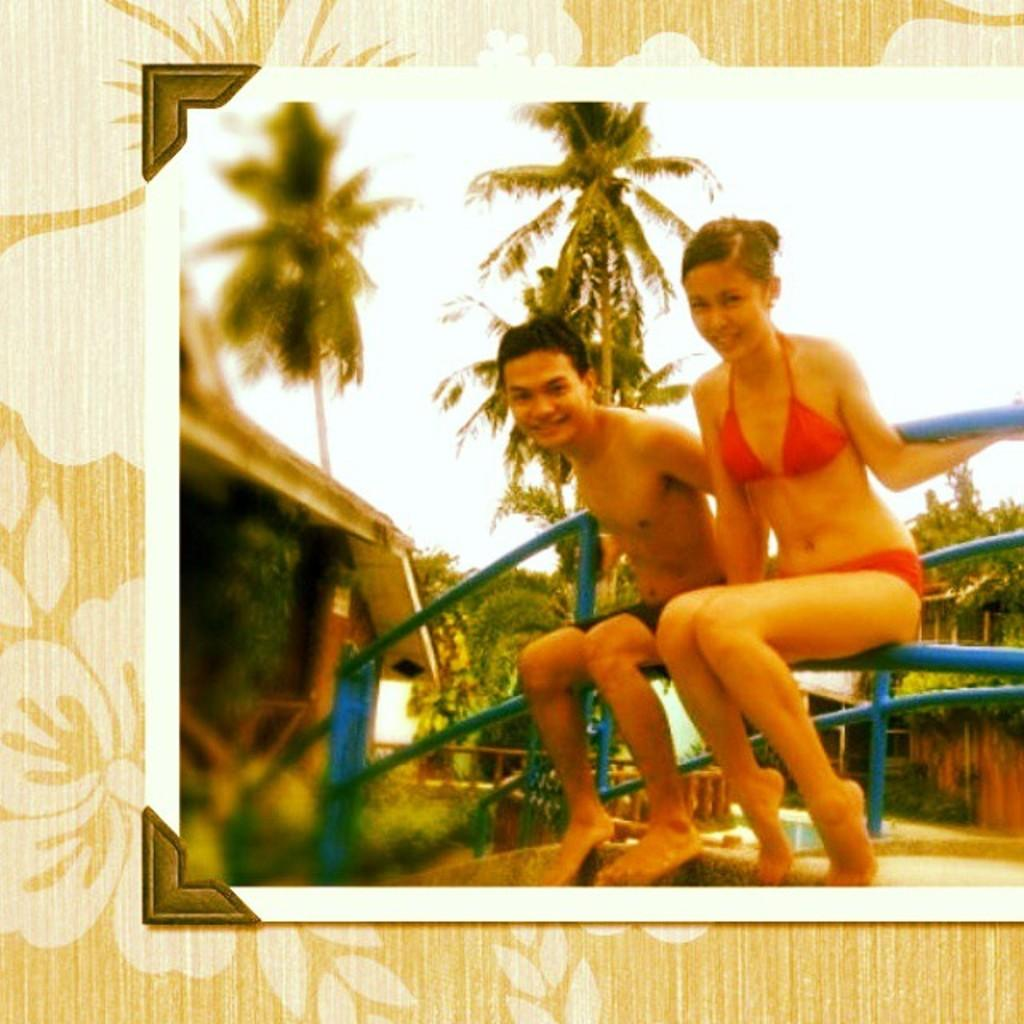How many people are in the image? There is a man and a woman in the image. What are the man and woman doing in the image? Both the man and woman are sitting on a railing. What can be seen in the background of the image? There are many trees in the background of the image. What type of object is the image contained within? The image is a photo frame. Can you describe the building visible in the image? The building is visible in the image, but it appears blurred. What rhythm is the boy dancing to in the image? There is no boy present in the image, and therefore no dancing or rhythm can be observed. 